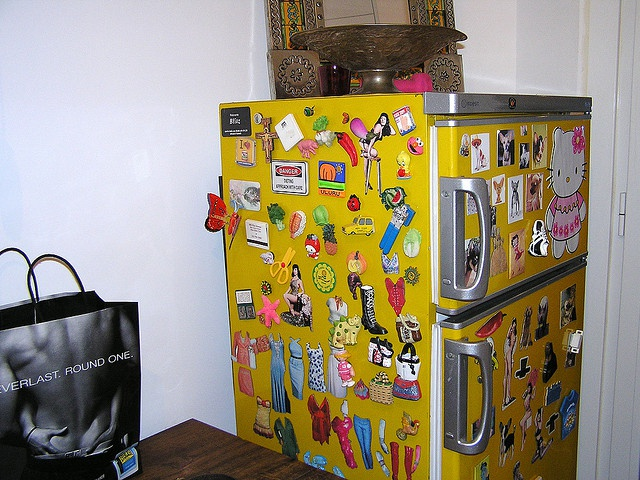Describe the objects in this image and their specific colors. I can see refrigerator in lightgray, olive, gold, and black tones, handbag in lightgray, black, gray, lavender, and darkgray tones, people in lightgray, black, gray, and darkgray tones, and scissors in lightgray, orange, olive, and gold tones in this image. 